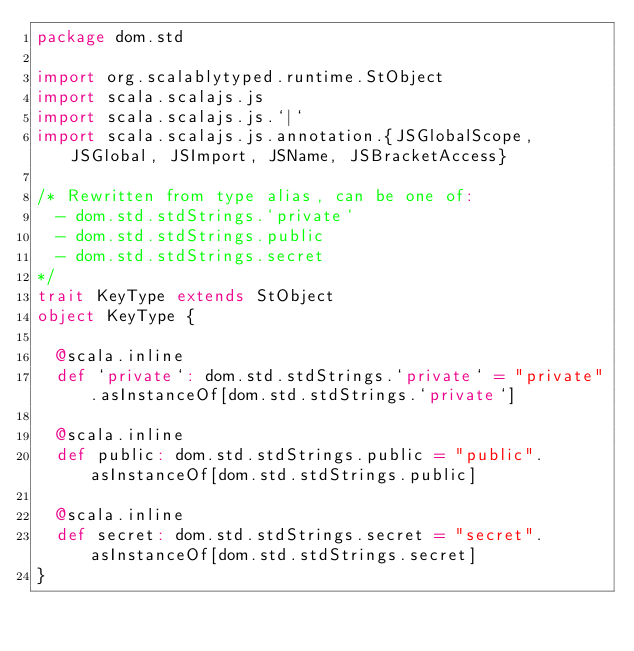Convert code to text. <code><loc_0><loc_0><loc_500><loc_500><_Scala_>package dom.std

import org.scalablytyped.runtime.StObject
import scala.scalajs.js
import scala.scalajs.js.`|`
import scala.scalajs.js.annotation.{JSGlobalScope, JSGlobal, JSImport, JSName, JSBracketAccess}

/* Rewritten from type alias, can be one of: 
  - dom.std.stdStrings.`private`
  - dom.std.stdStrings.public
  - dom.std.stdStrings.secret
*/
trait KeyType extends StObject
object KeyType {
  
  @scala.inline
  def `private`: dom.std.stdStrings.`private` = "private".asInstanceOf[dom.std.stdStrings.`private`]
  
  @scala.inline
  def public: dom.std.stdStrings.public = "public".asInstanceOf[dom.std.stdStrings.public]
  
  @scala.inline
  def secret: dom.std.stdStrings.secret = "secret".asInstanceOf[dom.std.stdStrings.secret]
}
</code> 